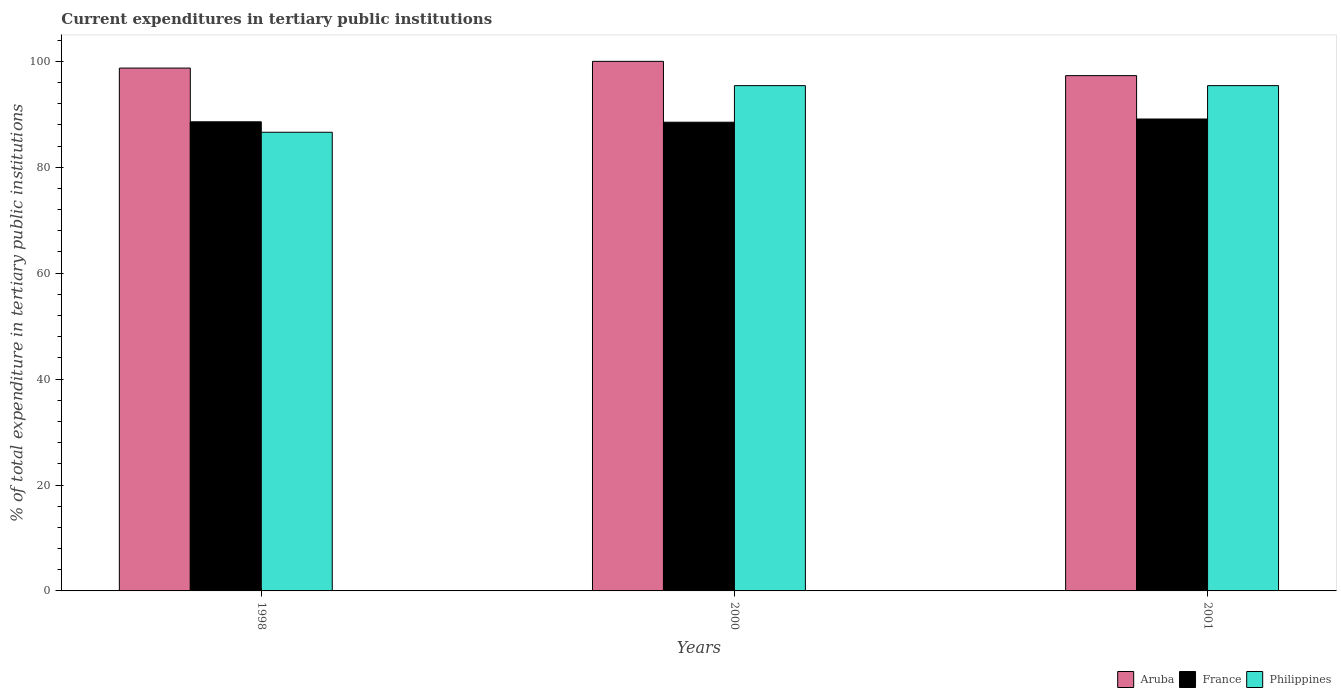How many different coloured bars are there?
Offer a very short reply. 3. How many groups of bars are there?
Offer a very short reply. 3. Are the number of bars per tick equal to the number of legend labels?
Provide a short and direct response. Yes. How many bars are there on the 1st tick from the left?
Provide a short and direct response. 3. What is the label of the 1st group of bars from the left?
Ensure brevity in your answer.  1998. What is the current expenditures in tertiary public institutions in France in 2000?
Give a very brief answer. 88.51. Across all years, what is the maximum current expenditures in tertiary public institutions in France?
Provide a short and direct response. 89.11. Across all years, what is the minimum current expenditures in tertiary public institutions in France?
Your response must be concise. 88.51. In which year was the current expenditures in tertiary public institutions in Aruba maximum?
Provide a short and direct response. 2000. In which year was the current expenditures in tertiary public institutions in France minimum?
Offer a very short reply. 2000. What is the total current expenditures in tertiary public institutions in Philippines in the graph?
Your response must be concise. 277.44. What is the difference between the current expenditures in tertiary public institutions in Aruba in 1998 and that in 2000?
Your answer should be compact. -1.27. What is the difference between the current expenditures in tertiary public institutions in Philippines in 2000 and the current expenditures in tertiary public institutions in Aruba in 1998?
Offer a terse response. -3.31. What is the average current expenditures in tertiary public institutions in Aruba per year?
Your response must be concise. 98.67. In the year 1998, what is the difference between the current expenditures in tertiary public institutions in Philippines and current expenditures in tertiary public institutions in France?
Provide a short and direct response. -1.97. In how many years, is the current expenditures in tertiary public institutions in France greater than 40 %?
Ensure brevity in your answer.  3. What is the ratio of the current expenditures in tertiary public institutions in France in 1998 to that in 2001?
Your answer should be compact. 0.99. Is the current expenditures in tertiary public institutions in France in 2000 less than that in 2001?
Provide a succinct answer. Yes. What is the difference between the highest and the second highest current expenditures in tertiary public institutions in France?
Ensure brevity in your answer.  0.53. What is the difference between the highest and the lowest current expenditures in tertiary public institutions in France?
Your answer should be very brief. 0.6. In how many years, is the current expenditures in tertiary public institutions in Philippines greater than the average current expenditures in tertiary public institutions in Philippines taken over all years?
Provide a succinct answer. 2. Is the sum of the current expenditures in tertiary public institutions in Philippines in 1998 and 2000 greater than the maximum current expenditures in tertiary public institutions in France across all years?
Your answer should be very brief. Yes. What does the 2nd bar from the left in 2001 represents?
Your answer should be compact. France. What does the 3rd bar from the right in 2001 represents?
Provide a succinct answer. Aruba. How many years are there in the graph?
Your answer should be compact. 3. What is the difference between two consecutive major ticks on the Y-axis?
Ensure brevity in your answer.  20. Where does the legend appear in the graph?
Your answer should be very brief. Bottom right. How many legend labels are there?
Your response must be concise. 3. What is the title of the graph?
Offer a very short reply. Current expenditures in tertiary public institutions. What is the label or title of the X-axis?
Make the answer very short. Years. What is the label or title of the Y-axis?
Give a very brief answer. % of total expenditure in tertiary public institutions. What is the % of total expenditure in tertiary public institutions of Aruba in 1998?
Ensure brevity in your answer.  98.73. What is the % of total expenditure in tertiary public institutions of France in 1998?
Provide a short and direct response. 88.58. What is the % of total expenditure in tertiary public institutions of Philippines in 1998?
Your answer should be compact. 86.61. What is the % of total expenditure in tertiary public institutions in Aruba in 2000?
Offer a terse response. 100. What is the % of total expenditure in tertiary public institutions in France in 2000?
Provide a succinct answer. 88.51. What is the % of total expenditure in tertiary public institutions of Philippines in 2000?
Your answer should be compact. 95.41. What is the % of total expenditure in tertiary public institutions of Aruba in 2001?
Give a very brief answer. 97.3. What is the % of total expenditure in tertiary public institutions in France in 2001?
Your answer should be very brief. 89.11. What is the % of total expenditure in tertiary public institutions of Philippines in 2001?
Make the answer very short. 95.41. Across all years, what is the maximum % of total expenditure in tertiary public institutions of Aruba?
Make the answer very short. 100. Across all years, what is the maximum % of total expenditure in tertiary public institutions in France?
Keep it short and to the point. 89.11. Across all years, what is the maximum % of total expenditure in tertiary public institutions in Philippines?
Make the answer very short. 95.41. Across all years, what is the minimum % of total expenditure in tertiary public institutions in Aruba?
Provide a short and direct response. 97.3. Across all years, what is the minimum % of total expenditure in tertiary public institutions of France?
Make the answer very short. 88.51. Across all years, what is the minimum % of total expenditure in tertiary public institutions of Philippines?
Provide a succinct answer. 86.61. What is the total % of total expenditure in tertiary public institutions of Aruba in the graph?
Provide a short and direct response. 296.02. What is the total % of total expenditure in tertiary public institutions of France in the graph?
Keep it short and to the point. 266.2. What is the total % of total expenditure in tertiary public institutions of Philippines in the graph?
Ensure brevity in your answer.  277.44. What is the difference between the % of total expenditure in tertiary public institutions in Aruba in 1998 and that in 2000?
Offer a terse response. -1.27. What is the difference between the % of total expenditure in tertiary public institutions in France in 1998 and that in 2000?
Your response must be concise. 0.08. What is the difference between the % of total expenditure in tertiary public institutions of Philippines in 1998 and that in 2000?
Provide a succinct answer. -8.8. What is the difference between the % of total expenditure in tertiary public institutions of Aruba in 1998 and that in 2001?
Provide a short and direct response. 1.42. What is the difference between the % of total expenditure in tertiary public institutions in France in 1998 and that in 2001?
Your answer should be very brief. -0.53. What is the difference between the % of total expenditure in tertiary public institutions of Philippines in 1998 and that in 2001?
Your answer should be compact. -8.8. What is the difference between the % of total expenditure in tertiary public institutions of Aruba in 2000 and that in 2001?
Your answer should be very brief. 2.7. What is the difference between the % of total expenditure in tertiary public institutions of France in 2000 and that in 2001?
Your response must be concise. -0.6. What is the difference between the % of total expenditure in tertiary public institutions of Aruba in 1998 and the % of total expenditure in tertiary public institutions of France in 2000?
Offer a very short reply. 10.22. What is the difference between the % of total expenditure in tertiary public institutions in Aruba in 1998 and the % of total expenditure in tertiary public institutions in Philippines in 2000?
Offer a very short reply. 3.31. What is the difference between the % of total expenditure in tertiary public institutions in France in 1998 and the % of total expenditure in tertiary public institutions in Philippines in 2000?
Provide a succinct answer. -6.83. What is the difference between the % of total expenditure in tertiary public institutions in Aruba in 1998 and the % of total expenditure in tertiary public institutions in France in 2001?
Provide a short and direct response. 9.61. What is the difference between the % of total expenditure in tertiary public institutions in Aruba in 1998 and the % of total expenditure in tertiary public institutions in Philippines in 2001?
Make the answer very short. 3.31. What is the difference between the % of total expenditure in tertiary public institutions of France in 1998 and the % of total expenditure in tertiary public institutions of Philippines in 2001?
Make the answer very short. -6.83. What is the difference between the % of total expenditure in tertiary public institutions in Aruba in 2000 and the % of total expenditure in tertiary public institutions in France in 2001?
Provide a short and direct response. 10.89. What is the difference between the % of total expenditure in tertiary public institutions in Aruba in 2000 and the % of total expenditure in tertiary public institutions in Philippines in 2001?
Offer a terse response. 4.58. What is the difference between the % of total expenditure in tertiary public institutions of France in 2000 and the % of total expenditure in tertiary public institutions of Philippines in 2001?
Offer a terse response. -6.91. What is the average % of total expenditure in tertiary public institutions of Aruba per year?
Give a very brief answer. 98.67. What is the average % of total expenditure in tertiary public institutions in France per year?
Make the answer very short. 88.73. What is the average % of total expenditure in tertiary public institutions of Philippines per year?
Your answer should be compact. 92.48. In the year 1998, what is the difference between the % of total expenditure in tertiary public institutions in Aruba and % of total expenditure in tertiary public institutions in France?
Offer a very short reply. 10.14. In the year 1998, what is the difference between the % of total expenditure in tertiary public institutions of Aruba and % of total expenditure in tertiary public institutions of Philippines?
Keep it short and to the point. 12.12. In the year 1998, what is the difference between the % of total expenditure in tertiary public institutions of France and % of total expenditure in tertiary public institutions of Philippines?
Your answer should be very brief. 1.97. In the year 2000, what is the difference between the % of total expenditure in tertiary public institutions of Aruba and % of total expenditure in tertiary public institutions of France?
Your response must be concise. 11.49. In the year 2000, what is the difference between the % of total expenditure in tertiary public institutions in Aruba and % of total expenditure in tertiary public institutions in Philippines?
Your answer should be compact. 4.58. In the year 2000, what is the difference between the % of total expenditure in tertiary public institutions in France and % of total expenditure in tertiary public institutions in Philippines?
Keep it short and to the point. -6.91. In the year 2001, what is the difference between the % of total expenditure in tertiary public institutions in Aruba and % of total expenditure in tertiary public institutions in France?
Make the answer very short. 8.19. In the year 2001, what is the difference between the % of total expenditure in tertiary public institutions of Aruba and % of total expenditure in tertiary public institutions of Philippines?
Keep it short and to the point. 1.89. In the year 2001, what is the difference between the % of total expenditure in tertiary public institutions of France and % of total expenditure in tertiary public institutions of Philippines?
Ensure brevity in your answer.  -6.3. What is the ratio of the % of total expenditure in tertiary public institutions in Aruba in 1998 to that in 2000?
Offer a terse response. 0.99. What is the ratio of the % of total expenditure in tertiary public institutions of Philippines in 1998 to that in 2000?
Give a very brief answer. 0.91. What is the ratio of the % of total expenditure in tertiary public institutions of Aruba in 1998 to that in 2001?
Your answer should be very brief. 1.01. What is the ratio of the % of total expenditure in tertiary public institutions of Philippines in 1998 to that in 2001?
Provide a short and direct response. 0.91. What is the ratio of the % of total expenditure in tertiary public institutions in Aruba in 2000 to that in 2001?
Keep it short and to the point. 1.03. What is the ratio of the % of total expenditure in tertiary public institutions in France in 2000 to that in 2001?
Ensure brevity in your answer.  0.99. What is the difference between the highest and the second highest % of total expenditure in tertiary public institutions in Aruba?
Make the answer very short. 1.27. What is the difference between the highest and the second highest % of total expenditure in tertiary public institutions in France?
Provide a succinct answer. 0.53. What is the difference between the highest and the second highest % of total expenditure in tertiary public institutions of Philippines?
Keep it short and to the point. 0. What is the difference between the highest and the lowest % of total expenditure in tertiary public institutions of Aruba?
Provide a short and direct response. 2.7. What is the difference between the highest and the lowest % of total expenditure in tertiary public institutions of France?
Your response must be concise. 0.6. What is the difference between the highest and the lowest % of total expenditure in tertiary public institutions of Philippines?
Offer a very short reply. 8.8. 